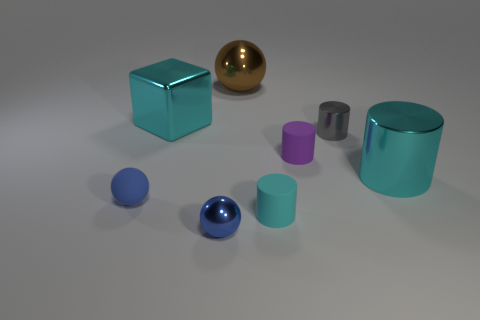Does the large metal cylinder have the same color as the cube?
Your answer should be very brief. Yes. There is a blue metallic object; what shape is it?
Ensure brevity in your answer.  Sphere. There is a metallic thing that is on the left side of the blue shiny sphere; what size is it?
Ensure brevity in your answer.  Large. The shiny block that is the same size as the brown metallic thing is what color?
Your answer should be very brief. Cyan. Is there a shiny thing that has the same color as the big metal cylinder?
Keep it short and to the point. Yes. Is the number of shiny objects right of the cyan rubber thing less than the number of gray cylinders behind the big sphere?
Your answer should be very brief. No. What material is the sphere that is in front of the purple cylinder and right of the large cyan shiny block?
Provide a succinct answer. Metal. There is a large brown object; does it have the same shape as the big cyan thing to the right of the cyan metal block?
Provide a succinct answer. No. How many other things are there of the same size as the brown thing?
Your answer should be compact. 2. Are there more spheres than cyan rubber spheres?
Provide a succinct answer. Yes. 